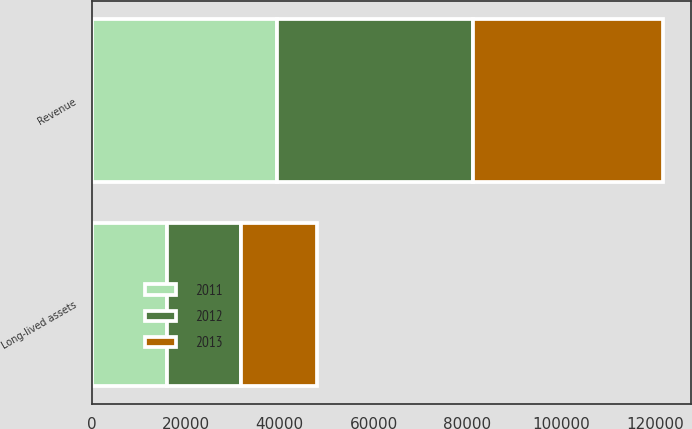Convert chart. <chart><loc_0><loc_0><loc_500><loc_500><stacked_bar_chart><ecel><fcel>Revenue<fcel>Long-lived assets<nl><fcel>2012<fcel>41772<fcel>15651<nl><fcel>2013<fcel>40428<fcel>16262<nl><fcel>2011<fcel>39347<fcel>16085<nl></chart> 